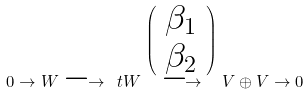Convert formula to latex. <formula><loc_0><loc_0><loc_500><loc_500>0 \to W \longrightarrow \ t W \stackrel { \left ( \begin{array} { c } \beta _ { 1 } \\ \beta _ { 2 } \end{array} \right ) } { \longrightarrow } V \oplus V \to 0</formula> 